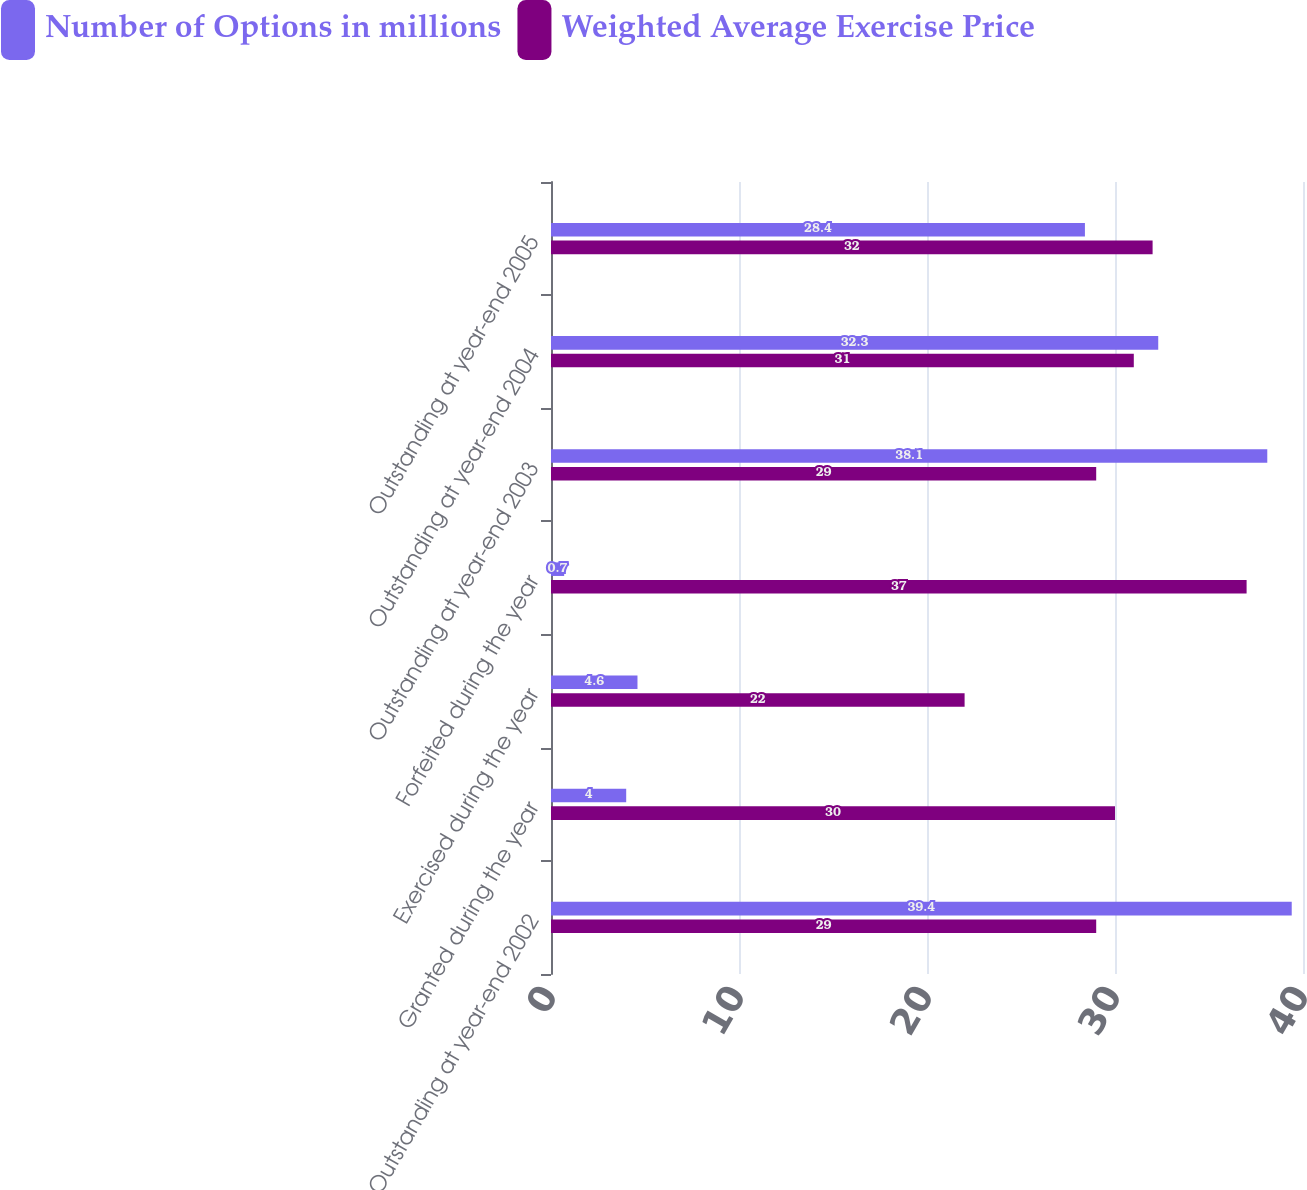Convert chart. <chart><loc_0><loc_0><loc_500><loc_500><stacked_bar_chart><ecel><fcel>Outstanding at year-end 2002<fcel>Granted during the year<fcel>Exercised during the year<fcel>Forfeited during the year<fcel>Outstanding at year-end 2003<fcel>Outstanding at year-end 2004<fcel>Outstanding at year-end 2005<nl><fcel>Number of Options in millions<fcel>39.4<fcel>4<fcel>4.6<fcel>0.7<fcel>38.1<fcel>32.3<fcel>28.4<nl><fcel>Weighted Average Exercise Price<fcel>29<fcel>30<fcel>22<fcel>37<fcel>29<fcel>31<fcel>32<nl></chart> 